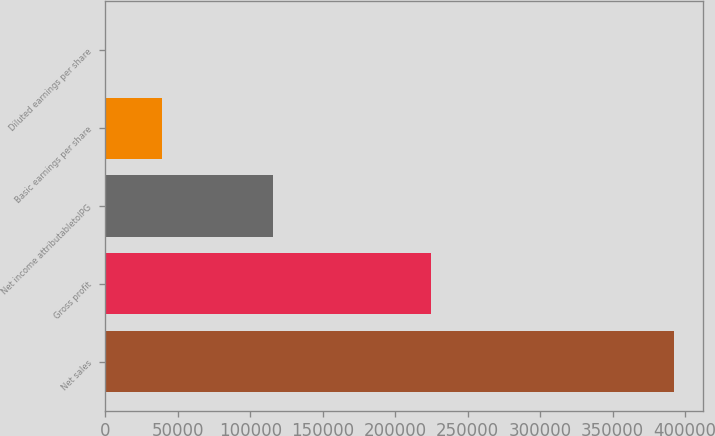Convert chart. <chart><loc_0><loc_0><loc_500><loc_500><bar_chart><fcel>Net sales<fcel>Gross profit<fcel>Net income attributabletoIPG<fcel>Basic earnings per share<fcel>Diluted earnings per share<nl><fcel>392615<fcel>224555<fcel>115597<fcel>39263.4<fcel>2.11<nl></chart> 